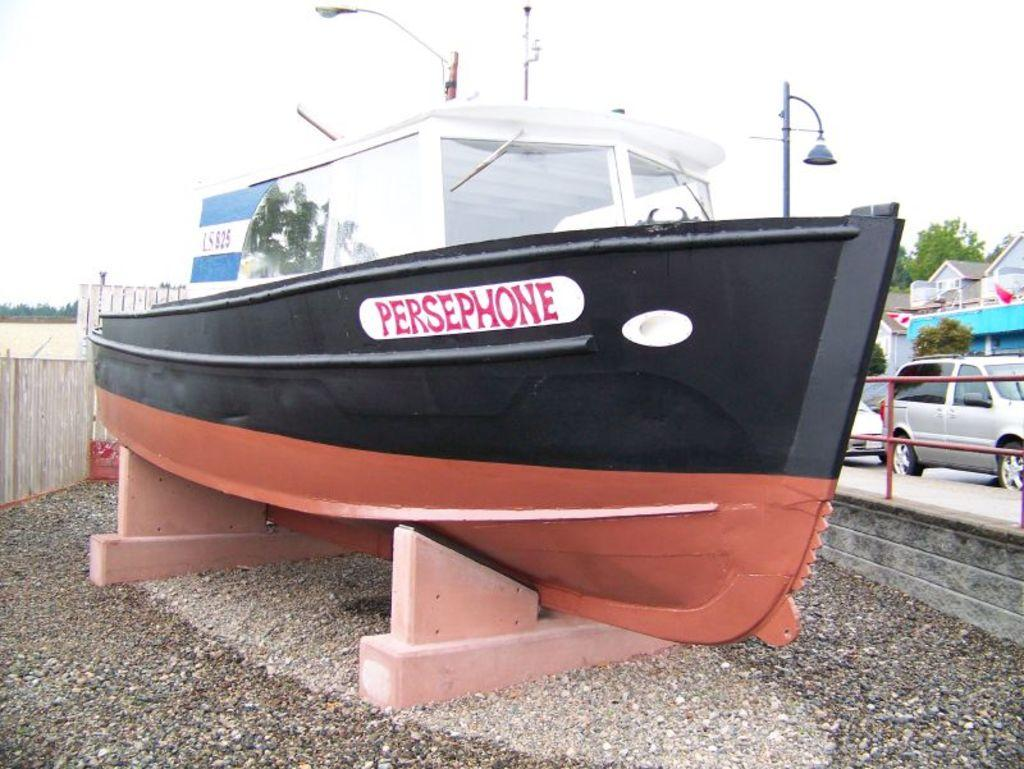What is the main subject of the image? There is a boat in the image. What can be seen on the right side of the image? There are trees, a building, and some fencing on the right side of the image. What type of environment is visible in the background of the image? Greenery is visible in the background of the image. What songs can be heard playing from the boat in the image? There is no indication in the image that there are songs playing from the boat, so it cannot be determined from the picture. 